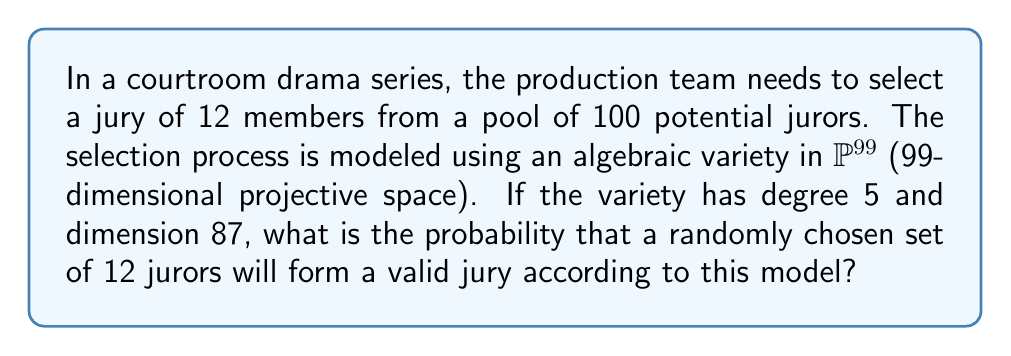Can you answer this question? Let's approach this step-by-step:

1) In algebraic geometry, the degree and dimension of a variety determine the number of points on the variety. For a variety $V$ in $\mathbb{P}^n$ of degree $d$ and dimension $k$, the number of points is approximately:

   $$\frac{d}{(n-k)!} \cdot \binom{100}{12}$$

2) In our case:
   $n = 99$ (99-dimensional projective space)
   $d = 5$ (degree of the variety)
   $k = 87$ (dimension of the variety)

3) Substituting these values:

   $$\frac{5}{(99-87)!} \cdot \binom{100}{12} = \frac{5}{12!} \cdot \binom{100}{12}$$

4) Calculate $\binom{100}{12}$:
   
   $$\binom{100}{12} = \frac{100!}{12!(100-12)!} = \frac{100!}{12!88!}$$

5) The total number of possible 12-person juries from 100 people is $\binom{100}{12}$.

6) Therefore, the probability is:

   $$P = \frac{\frac{5}{12!} \cdot \frac{100!}{12!88!}}{\frac{100!}{12!88!}} = \frac{5}{12!}$$

7) Simplify:
   
   $$P = \frac{5}{479,001,600} = \frac{1}{95,800,320}$$
Answer: $\frac{1}{95,800,320}$ 